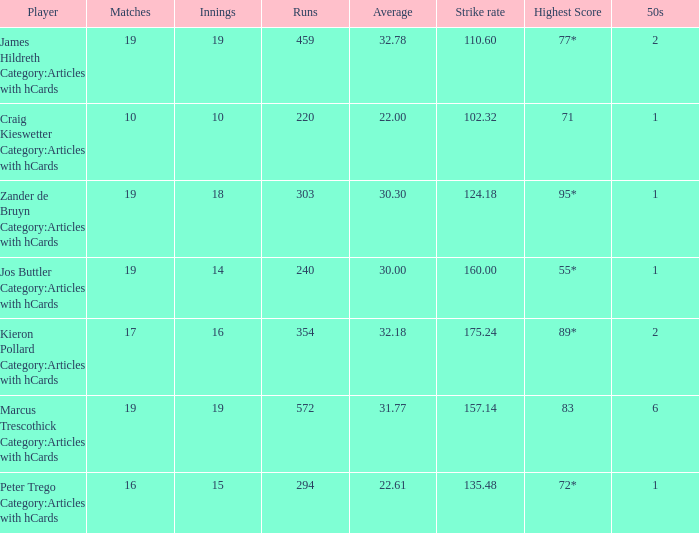What is the strike rate for the player with an average of 32.78? 110.6. 